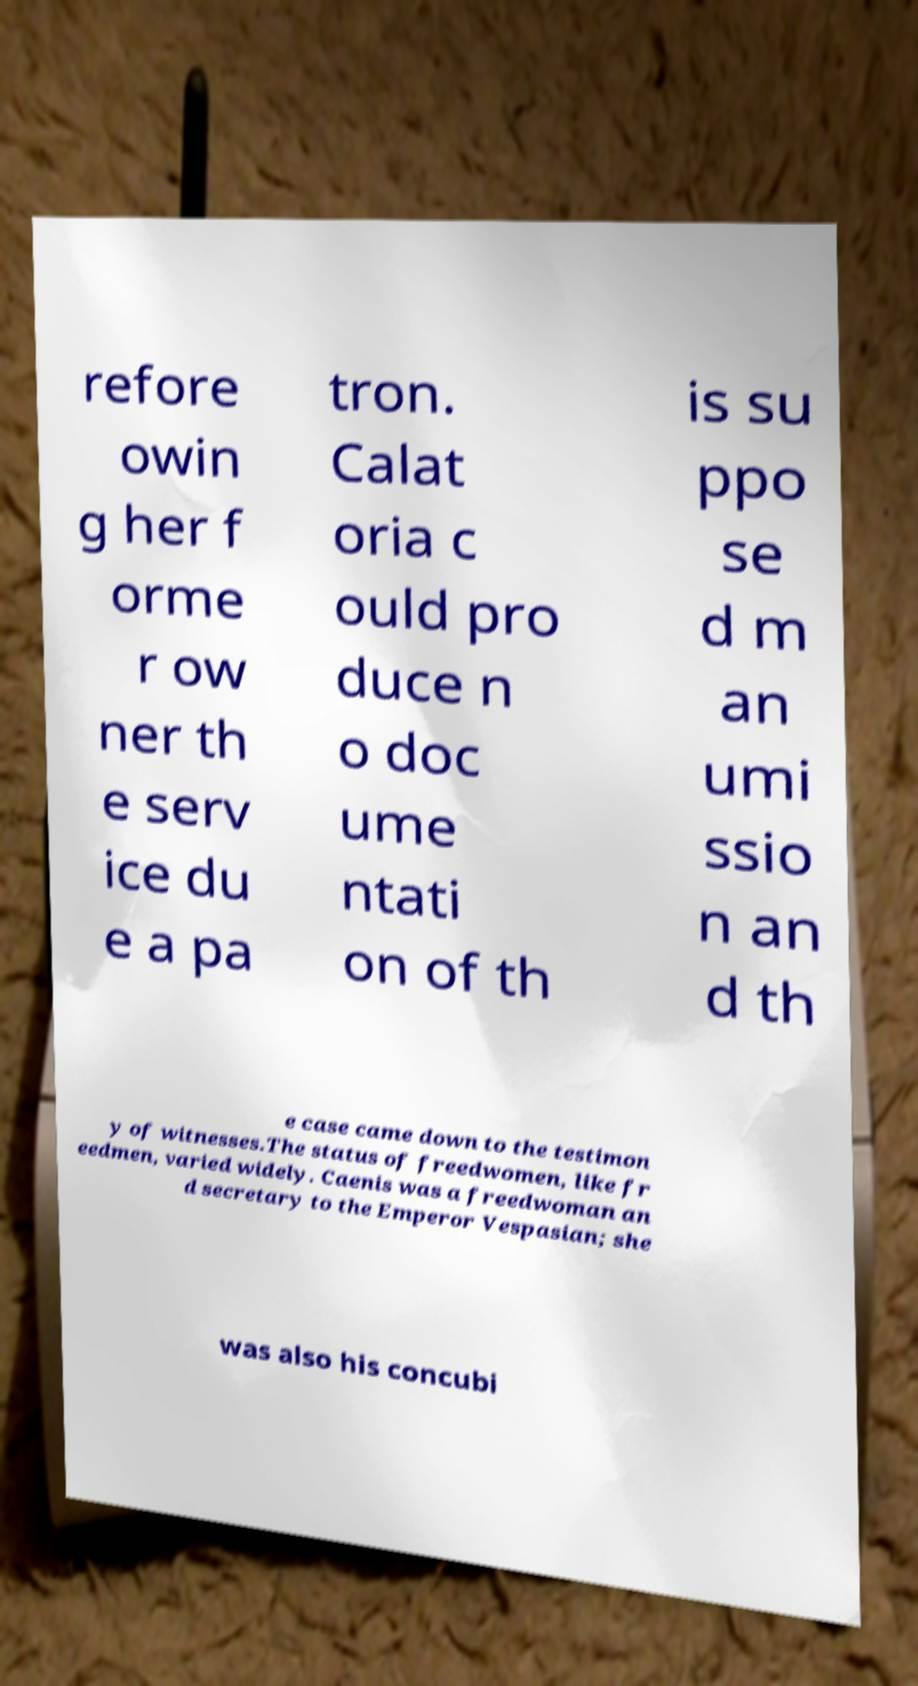Could you extract and type out the text from this image? refore owin g her f orme r ow ner th e serv ice du e a pa tron. Calat oria c ould pro duce n o doc ume ntati on of th is su ppo se d m an umi ssio n an d th e case came down to the testimon y of witnesses.The status of freedwomen, like fr eedmen, varied widely. Caenis was a freedwoman an d secretary to the Emperor Vespasian; she was also his concubi 